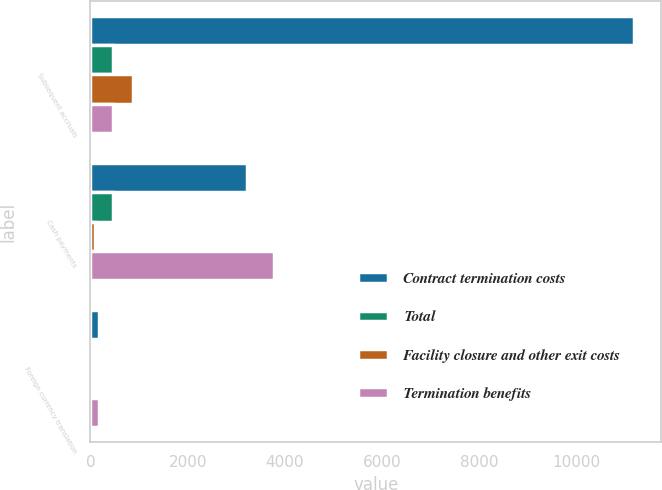Convert chart. <chart><loc_0><loc_0><loc_500><loc_500><stacked_bar_chart><ecel><fcel>Subsequent accruals<fcel>Cash payments<fcel>Foreign currency translation<nl><fcel>Contract termination costs<fcel>11176<fcel>3220<fcel>179<nl><fcel>Total<fcel>468<fcel>469<fcel>1<nl><fcel>Facility closure and other exit costs<fcel>866<fcel>95<fcel>11<nl><fcel>Termination benefits<fcel>468<fcel>3784<fcel>169<nl></chart> 